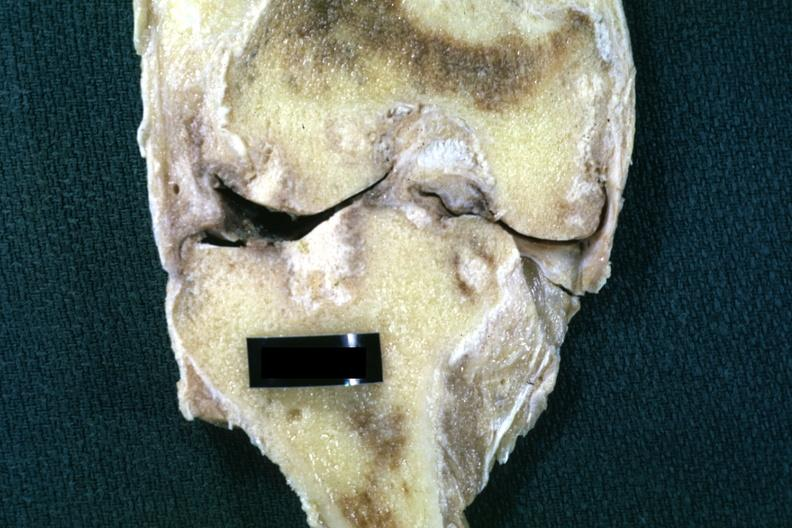s joints present?
Answer the question using a single word or phrase. Yes 